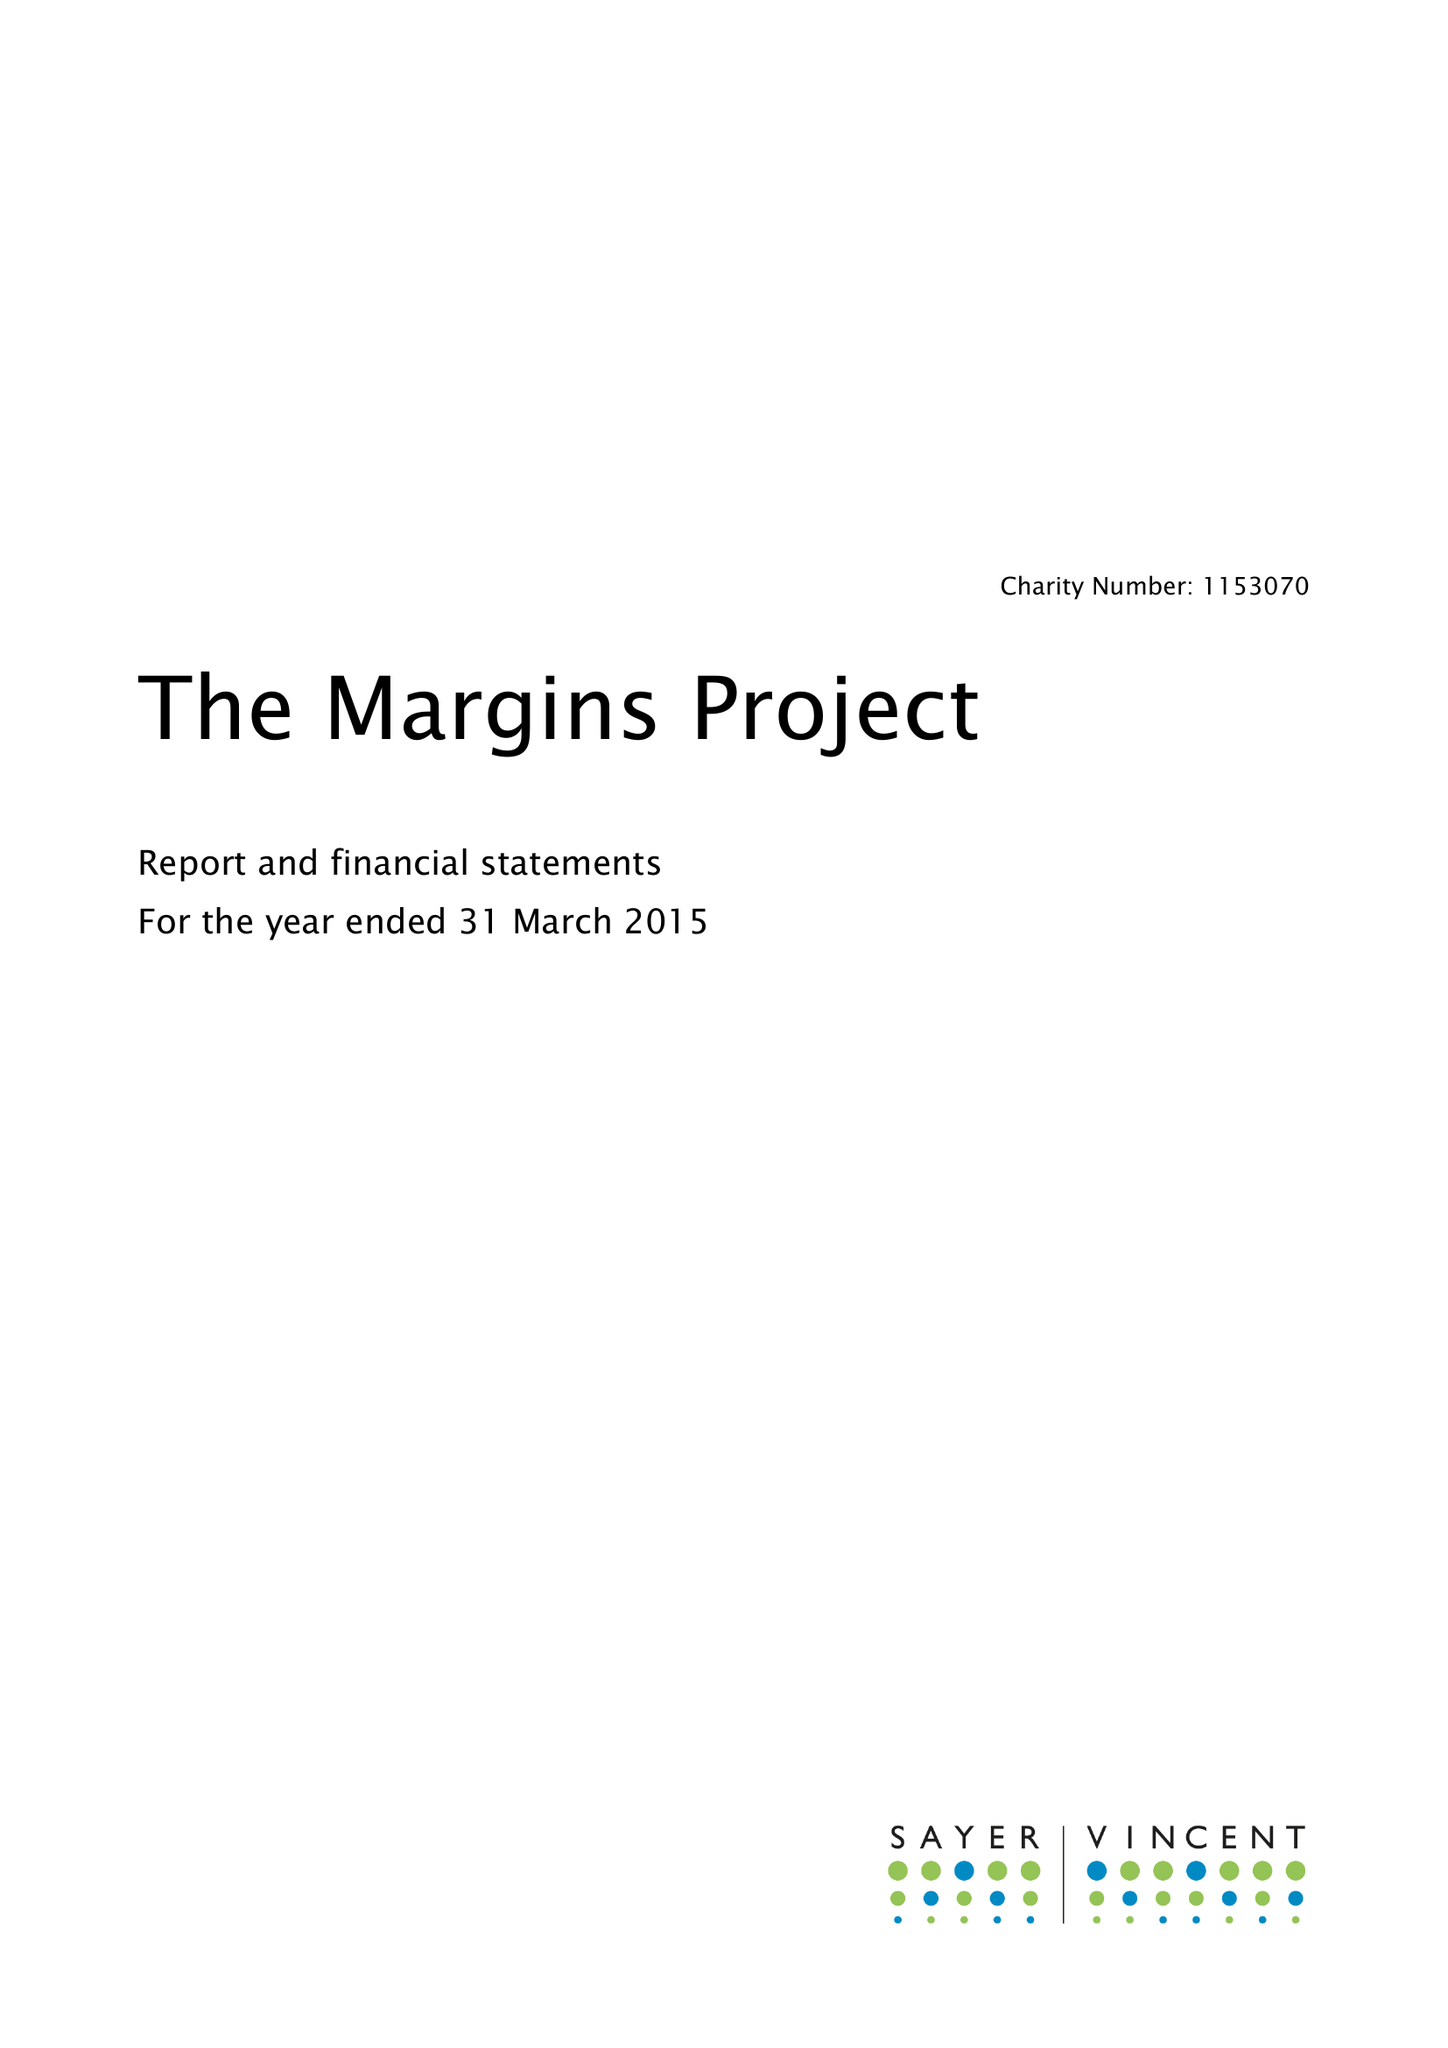What is the value for the address__street_line?
Answer the question using a single word or phrase. 19B COMPTON TERRACE 